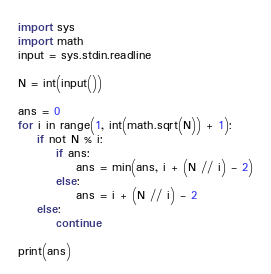Convert code to text. <code><loc_0><loc_0><loc_500><loc_500><_Python_>import sys
import math
input = sys.stdin.readline

N = int(input())

ans = 0
for i in range(1, int(math.sqrt(N)) + 1):
    if not N % i:
        if ans:
            ans = min(ans, i + (N // i) - 2)
        else:
            ans = i + (N // i) - 2
    else:
        continue

print(ans)</code> 